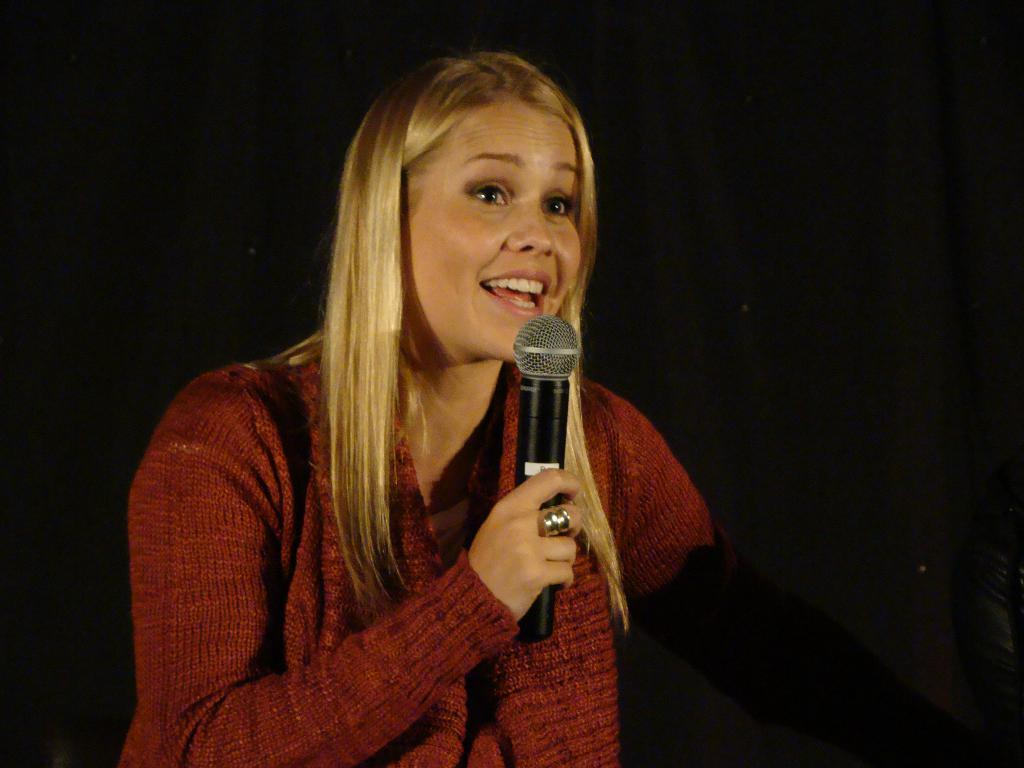Who is the main subject in the image? There is a woman in the image. What is the woman holding in her hand? The woman is holding a mic in her hand. Is there any visible pollution in the image? There is no information about pollution in the image, as it only features a woman holding a mic. 